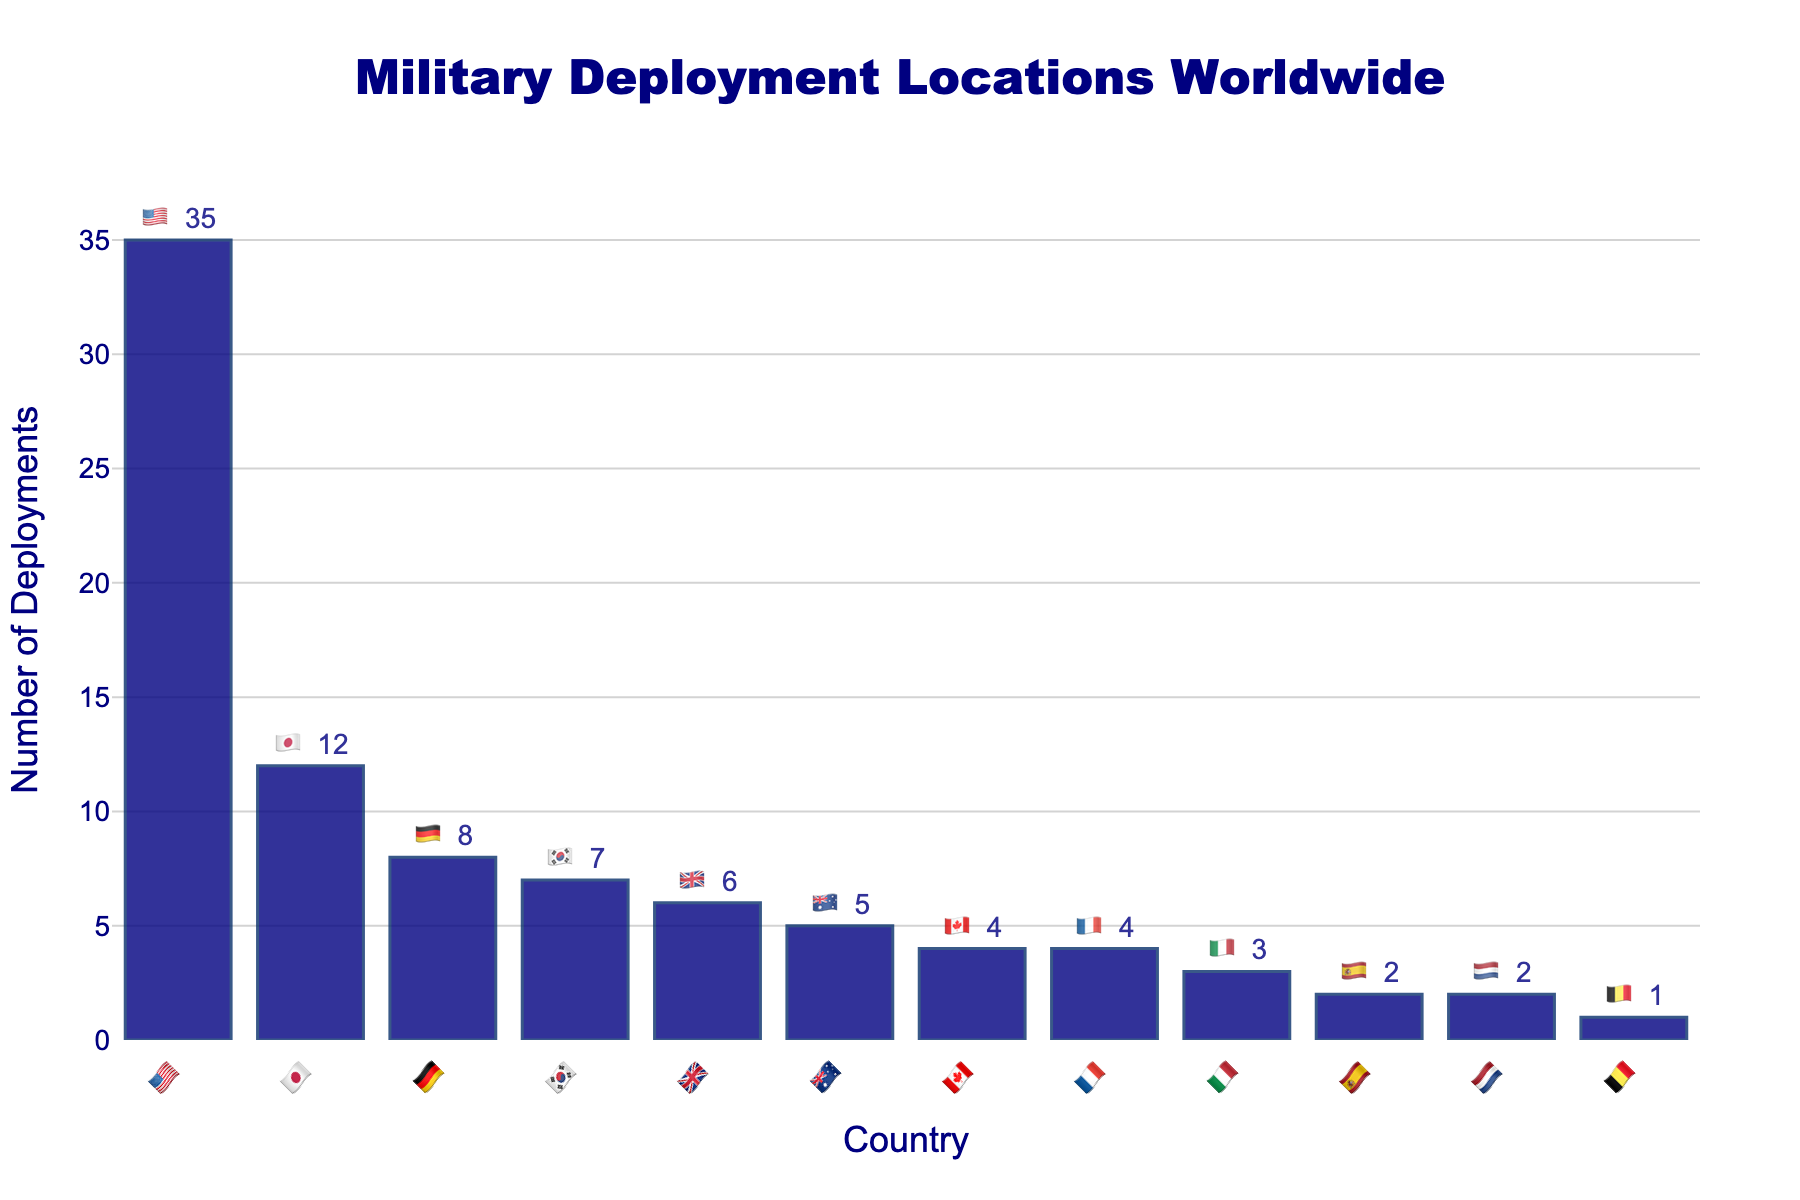What's the title of the figure? The title is displayed at the top center of the figure and reads "Military Deployment Locations Worldwide".
Answer: Military Deployment Locations Worldwide Which country has the highest number of deployments? By looking at the bar heights and labels, the country with the highest number of deployments is represented by 🇺🇸.
Answer: 🇺🇸 How many more deployments does 🇺🇸 have compared to 🇯🇵? 🇺🇸 has 35 deployments and 🇯🇵 has 12 deployments. The difference can be calculated by 35 - 12 = 23.
Answer: 23 What's the total number of deployments for the top three countries (🇺🇸, 🇯🇵, 🇩🇪)? The sum of deployments for 🇺🇸 (35), 🇯🇵 (12), and 🇩🇪 (8) is 35 + 12 + 8 = 55.
Answer: 55 Which country has the smallest number of deployments? The shortest bar on the figure represents 🇧🇪 with 1 deployment.
Answer: 🇧🇪 How many countries have deployment counts greater than 5? By counting the bars with heights representing deployment counts greater than 5, we have 🇺🇸, 🇯🇵, 🇩🇪, 🇰🇷, and 🇬🇧, making a total of 5 countries.
Answer: 5 What percentage of the total 89 deployments are attributed to 🇺🇸? The total deployments are 89, and 🇺🇸 has 35 deployments. The percentage is (35/89)*100 ≈ 39.33%.
Answer: 39.33% Which countries have an equal number of deployments? 🇨🇦 and 🇫🇷 both have 4 deployments each, and 🇪🇸 and 🇳🇱 both have 2 deployments each.
Answer: 🇨🇦, 🇫🇷; 🇪🇸, 🇳🇱 How many deployments are there in total? Summing up all the deployments, we get 35 (🇺🇸) + 12 (🇯🇵) + 8 (🇩🇪) + 7 (🇰🇷) + 6 (🇬🇧) + 5 (🇦🇺) + 4 (🇨🇦) + 4 (🇫🇷) + 3 (🇮🇹) + 2 (🇪🇸) + 2 (🇳🇱) + 1 (🇧🇪) = 89.
Answer: 89 